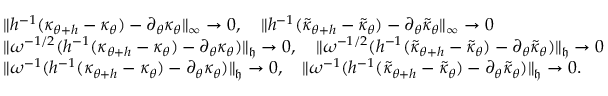<formula> <loc_0><loc_0><loc_500><loc_500>\begin{array} { r l } & { \| h ^ { - 1 } ( \kappa _ { \theta + h } - \kappa _ { \theta } ) - \partial _ { \theta } \kappa _ { \theta } \| _ { \infty } \to 0 , \quad \| h ^ { - 1 } ( \tilde { \kappa } _ { \theta + h } - \tilde { \kappa } _ { \theta } ) - \partial _ { \theta } \tilde { \kappa } _ { \theta } \| _ { \infty } \to 0 } \\ & { \| \omega ^ { - 1 / 2 } ( h ^ { - 1 } ( \kappa _ { \theta + h } - \kappa _ { \theta } ) - \partial _ { \theta } \kappa _ { \theta } ) \| _ { \mathfrak { h } } \to 0 , \quad \| \omega ^ { - 1 / 2 } ( h ^ { - 1 } ( \tilde { \kappa } _ { \theta + h } - \tilde { \kappa } _ { \theta } ) - \partial _ { \theta } \tilde { \kappa } _ { \theta } ) \| _ { \mathfrak { h } } \to 0 } \\ & { \| \omega ^ { - 1 } ( h ^ { - 1 } ( \kappa _ { \theta + h } - \kappa _ { \theta } ) - \partial _ { \theta } \kappa _ { \theta } ) \| _ { \mathfrak { h } } \to 0 , \quad \| \omega ^ { - 1 } ( h ^ { - 1 } ( \tilde { \kappa } _ { \theta + h } - \tilde { \kappa } _ { \theta } ) - \partial _ { \theta } \tilde { \kappa } _ { \theta } ) \| _ { \mathfrak { h } } \to 0 . } \end{array}</formula> 